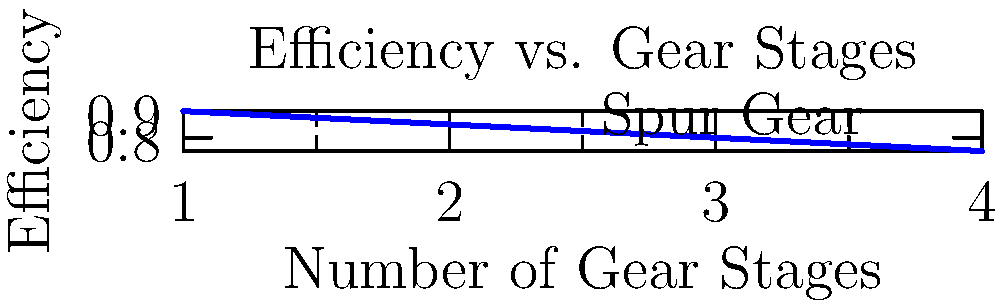In a power transmission system, multiple gear stages are sometimes necessary. However, each stage introduces some power loss due to friction and other factors. The graph shows the efficiency of a spur gear system as the number of gear stages increases. If a system requires four gear stages for the desired speed reduction, what percentage of the input power is lost in transmission? To solve this problem, we need to follow these steps:

1. Understand the graph:
   - The x-axis represents the number of gear stages
   - The y-axis represents the efficiency of the system

2. Identify the efficiency for four gear stages:
   - From the graph, we can see that for 4 gear stages, the efficiency is 0.75 or 75%

3. Calculate the power loss:
   - Efficiency = Output Power / Input Power
   - 0.75 = Output Power / Input Power
   - Output Power = 0.75 * Input Power

4. Calculate the percentage of power lost:
   - Power Lost = Input Power - Output Power
   - Power Lost = Input Power - (0.75 * Input Power)
   - Power Lost = 0.25 * Input Power

5. Express the power loss as a percentage:
   - Percentage of power lost = (Power Lost / Input Power) * 100%
   - Percentage of power lost = (0.25 * Input Power / Input Power) * 100%
   - Percentage of power lost = 0.25 * 100% = 25%

Therefore, 25% of the input power is lost in transmission when using four gear stages.
Answer: 25% 